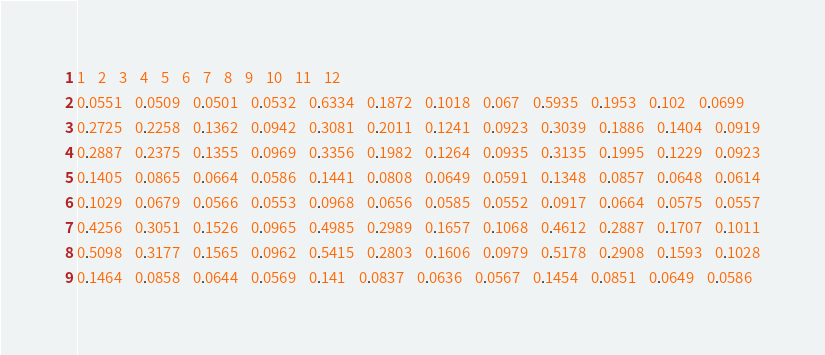Convert code to text. <code><loc_0><loc_0><loc_500><loc_500><_SQL_>1	2	3	4	5	6	7	8	9	10	11	12
0.0551	0.0509	0.0501	0.0532	0.6334	0.1872	0.1018	0.067	0.5935	0.1953	0.102	0.0699
0.2725	0.2258	0.1362	0.0942	0.3081	0.2011	0.1241	0.0923	0.3039	0.1886	0.1404	0.0919
0.2887	0.2375	0.1355	0.0969	0.3356	0.1982	0.1264	0.0935	0.3135	0.1995	0.1229	0.0923
0.1405	0.0865	0.0664	0.0586	0.1441	0.0808	0.0649	0.0591	0.1348	0.0857	0.0648	0.0614
0.1029	0.0679	0.0566	0.0553	0.0968	0.0656	0.0585	0.0552	0.0917	0.0664	0.0575	0.0557
0.4256	0.3051	0.1526	0.0965	0.4985	0.2989	0.1657	0.1068	0.4612	0.2887	0.1707	0.1011
0.5098	0.3177	0.1565	0.0962	0.5415	0.2803	0.1606	0.0979	0.5178	0.2908	0.1593	0.1028
0.1464	0.0858	0.0644	0.0569	0.141	0.0837	0.0636	0.0567	0.1454	0.0851	0.0649	0.0586
</code> 